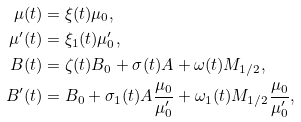<formula> <loc_0><loc_0><loc_500><loc_500>\mu ( t ) & = \xi ( t ) \mu _ { 0 } , \\ \mu ^ { \prime } ( t ) & = \xi _ { 1 } ( t ) \mu ^ { \prime } _ { 0 } , \\ B ( t ) & = \zeta ( t ) B _ { 0 } + \sigma ( t ) A + \omega ( t ) M _ { 1 / 2 } , \\ B ^ { \prime } ( t ) & = B _ { 0 } + \sigma _ { 1 } ( t ) A \frac { \mu _ { 0 } } { \mu ^ { \prime } _ { 0 } } + \omega _ { 1 } ( t ) M _ { 1 / 2 } \frac { \mu _ { 0 } } { \mu ^ { \prime } _ { 0 } } ,</formula> 